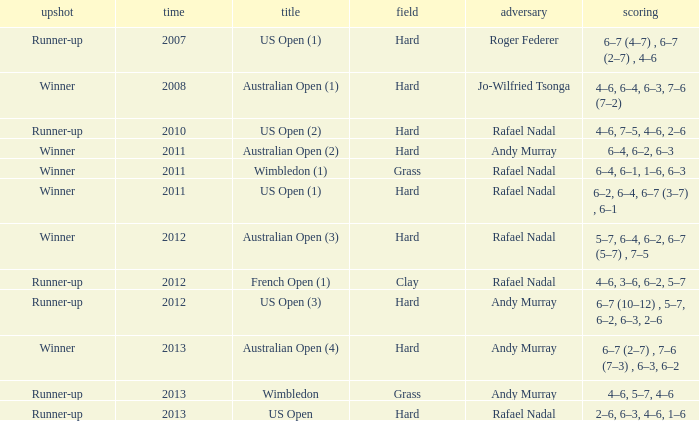What is the outcome of the 4–6, 6–4, 6–3, 7–6 (7–2) score? Winner. 